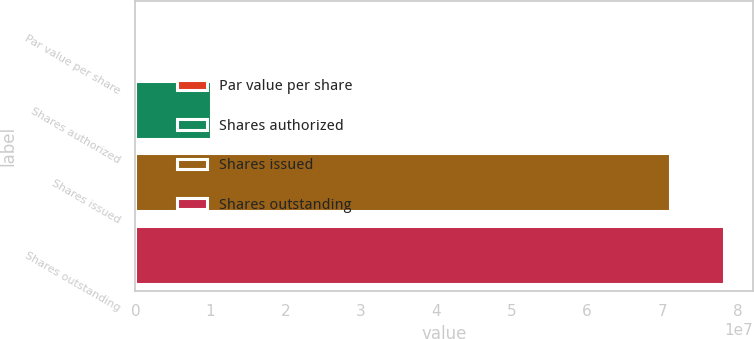Convert chart. <chart><loc_0><loc_0><loc_500><loc_500><bar_chart><fcel>Par value per share<fcel>Shares authorized<fcel>Shares issued<fcel>Shares outstanding<nl><fcel>0.01<fcel>1e+07<fcel>7.1099e+07<fcel>7.82088e+07<nl></chart> 